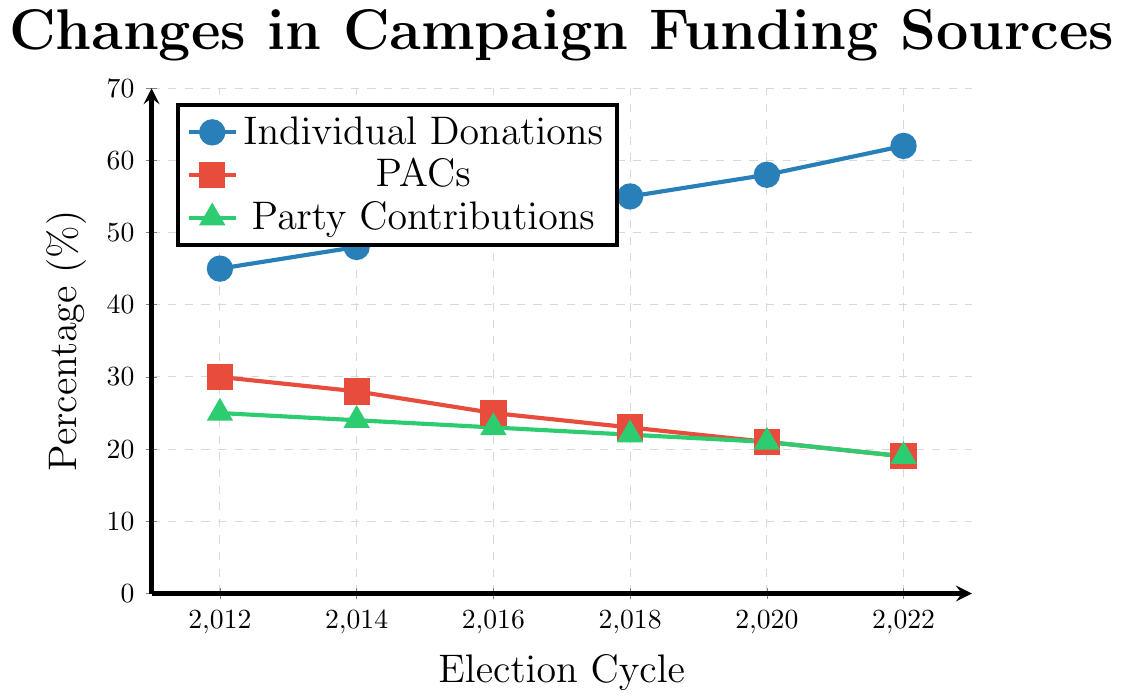What was the percentage increase in Individual Donations from 2012 to 2022? Individual Donations were 45% in 2012 and 62% in 2022. The percentage increase is calculated as ((62 - 45) / 45) * 100. This results in an increase of (17 / 45) * 100 = 37.78%
Answer: 37.78% Which funding source has shown a consistent decrease over the years? Both PACs and Party Contributions have shown consistent decreases. PACs decreased from 30% in 2012 to 19% in 2022, and Party Contributions decreased from 25% in 2012 to 19% in 2022.
Answer: PACs and Party Contributions By how much did PACs' contributions decrease between the 2014 and 2022 election cycles? In 2014, PACs' contributions were 28%, and in 2022, they were 19%. The decrease can be calculated as 28 - 19, which is 9%.
Answer: 9% Between which two consecutive election cycles did Individual Donations see the largest increase, and by how much? The largest increase for Individual Donations occurred between 2016 (52%) and 2018 (55%). The increase can be calculated as 55 - 52, which is 3%.
Answer: 2016 to 2018, 3% What is the average percentage of Party Contributions over all election cycles shown? The average percentage of Party Contributions is calculated by taking the sum of all values (25, 24, 23, 22, 21, 19) and dividing by the number of election cycles (6). The sum is 134, and the average is 134 / 6 = 22.33%.
Answer: 22.33% Comparing Individual Donations in 2016 and PACs' contributions in 2022, which was higher and by how much? Individual Donations in 2016 were 52%, while PACs' contributions in 2022 were 19%. The difference is 52 - 19 = 33%. Individual Donations in 2016 were higher by 33%.
Answer: Individual Donations by 33% Did any funding source remain the same between any of the election cycles? No funding source remained the same between any of the election cycles. Every source showed some change in percentage across all cycles.
Answer: No Which funding source has the highest percentage in 2022, and what is that percentage? In 2022, Individual Donations had the highest percentage at 62%.
Answer: Individual Donations, 62% What is the combined percentage of Individual Donations and Party Contributions in 2014? In 2014, Individual Donations were 48% and Party Contributions were 24%. The combined percentage is 48 + 24, which is 72%.
Answer: 72% How much did Party Contributions decrease from 2012 to 2020? Party Contributions in 2012 were 25% and in 2020 they were 21%. The decrease can be calculated as 25 - 21, which is 4%.
Answer: 4% 